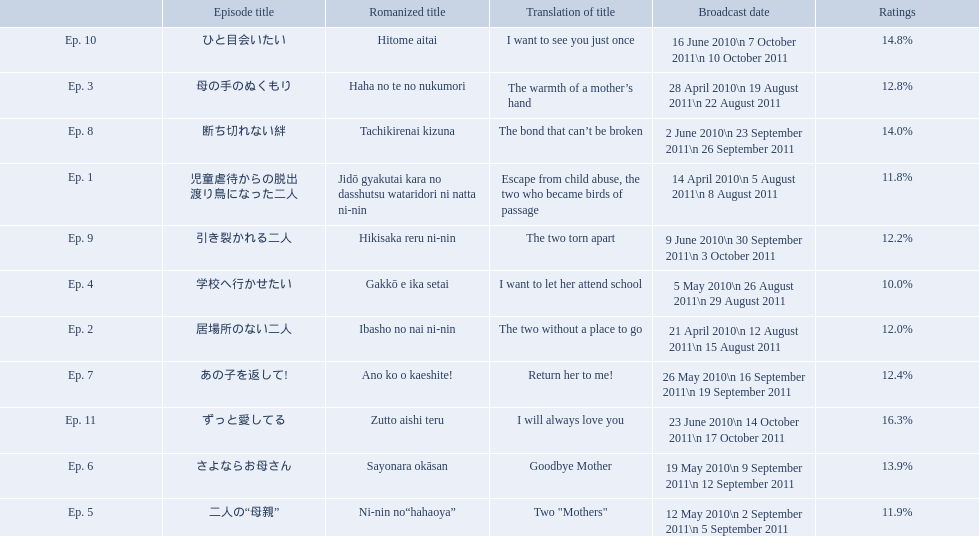Which episode had the highest ratings? Ep. 11. Which episode was named haha no te no nukumori? Ep. 3. Besides episode 10 which episode had a 14% rating? Ep. 8. 